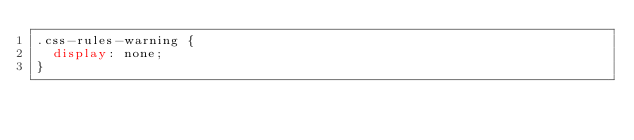<code> <loc_0><loc_0><loc_500><loc_500><_CSS_>.css-rules-warning {
  display: none;
}
</code> 